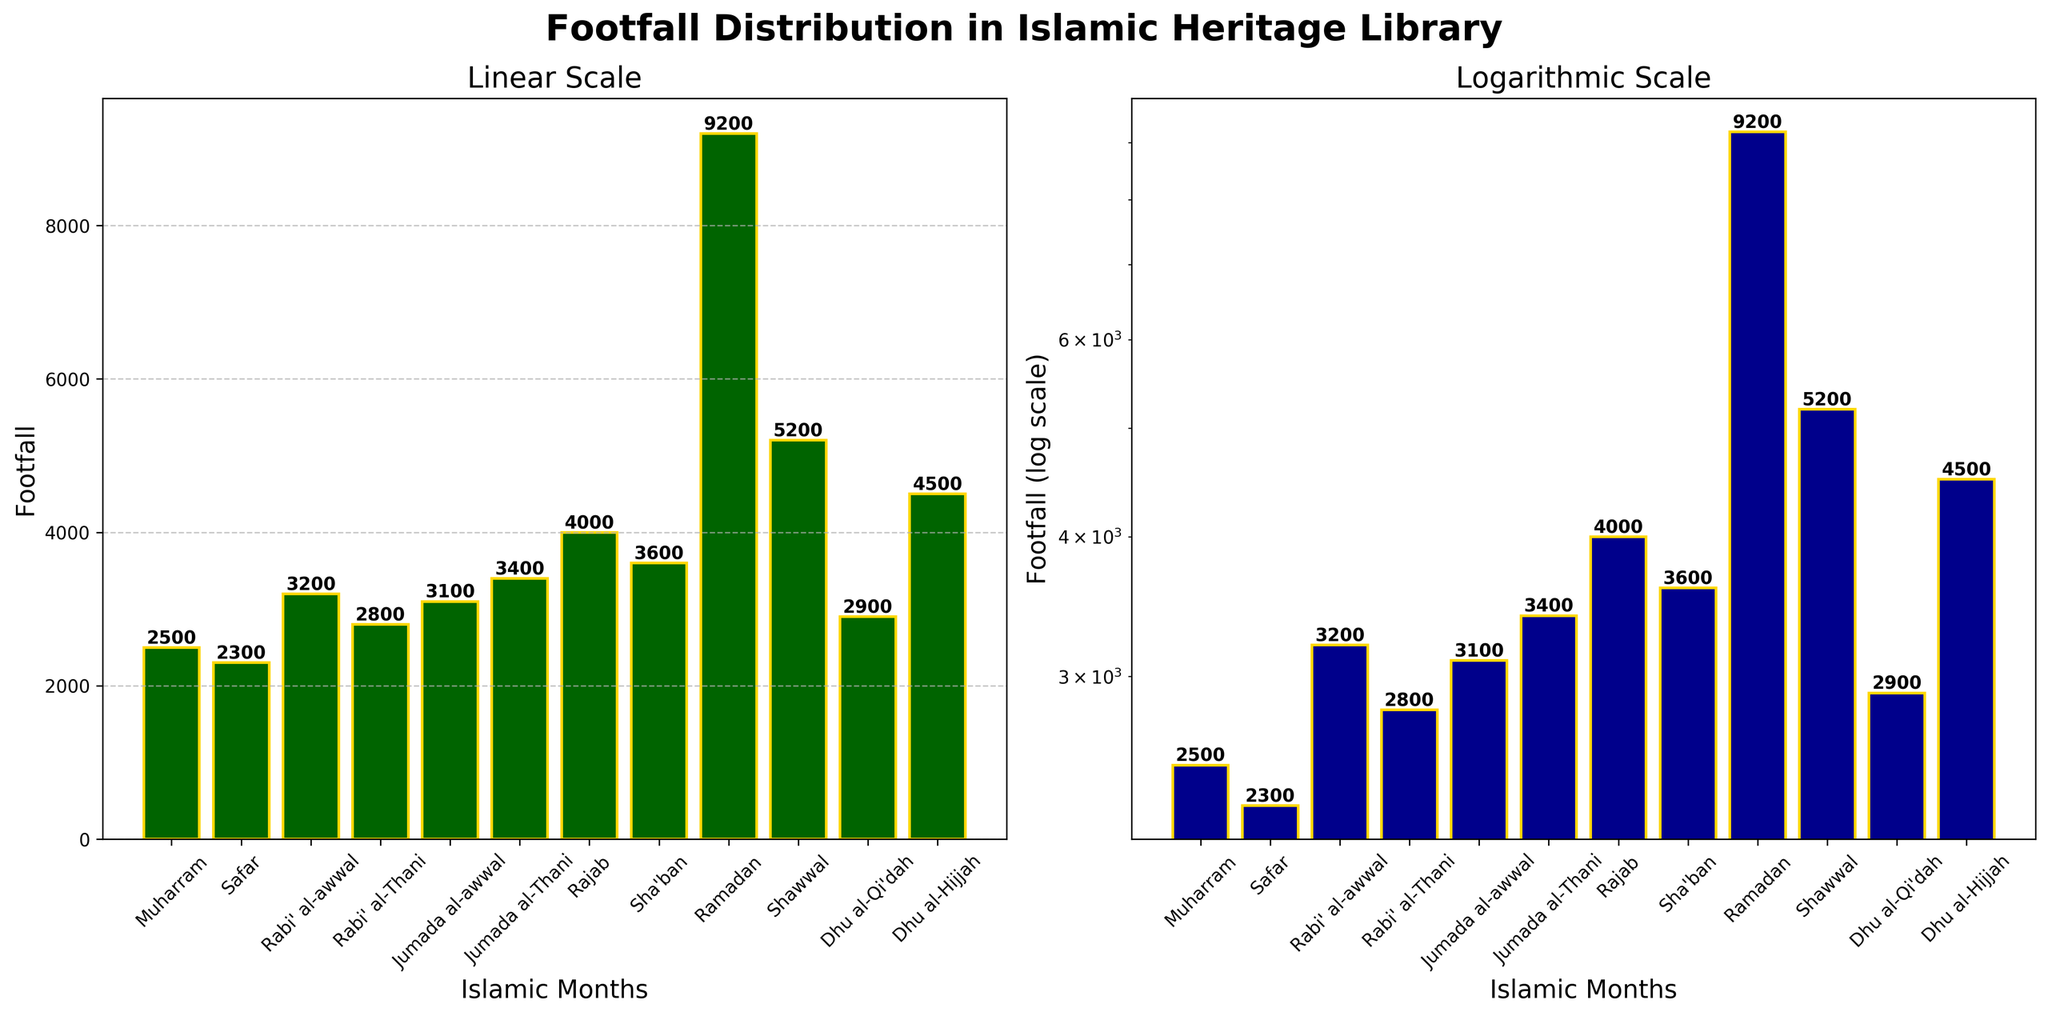Which month experiences the highest footfall? In both the linear and logarithmic scale plots, the month with the highest bar is Ramadan. This height indicates the highest footfall, which is shown as 9200.
Answer: Ramadan Which month experiences the lowest footfall? In both plots, the height of the bars can be compared. The shortest bar corresponds to Safar, indicating a footfall of 2300, which is the lowest.
Answer: Safar How does the footfall in Shawwal compare to that in Sha'ban? In the linear plot, the bar for Shawwal is notable for being taller, indicating a higher footfall. Shawwal has 5200 footfalls, whereas Sha'ban has 3600.
Answer: Shawwal is higher What is the total footfall during the first three months? Sum the footfall values of Muharram (2500), Safar (2300), and Rabi' al-awwal (3200): 2500 + 2300 + 3200 = 8000.
Answer: 8000 Which months have footfall counts that are above 4000? Checking both plots, the months with bars surpassing the 4000 mark are Rajab (4000), Ramadan (9200), Shawwal (5200), and Dhu al-Hijjah (4500).
Answer: Rajab, Ramadan, Shawwal, Dhu al-Hijjah How much more footfall does Ramadan have compared to Muharram? The footfall for Ramadan and Muharram are 9200 and 2500 respectively. Subtract Muharram's footfall from Ramadan’s: 9200 - 2500 = 6700.
Answer: 6700 What is the average footfall across all months? Sum all the footfalls and divide by 12: (2500 + 2300 + 3200 + 2800 + 3100 + 3400 + 4000 + 3600 + 9200 + 5200 + 2900 + 4500) / 12 = 45,700 / 12 ≈ 3808.33.
Answer: ≈ 3808.33 Explain the trend in footfall during Ramadan using the log scale plot. On the log scale, Ramadan's bar is the tallest, indicating a significant increase compared to other months. This suggests a sharp rise in footfall during Ramadan, far more pronounced based on the logarithmic representation.
Answer: Significant increase Compare the footfall distribution in linear and log scales. The linear scale shows absolute differences, indicating Ramadan’s footfall as extremely high. The log scale compresses the differences but emphasizes proportional changes, still reflecting Ramadan’s high footfall distinctly.
Answer: Linear: absolute; Log: proportional Which months show a footfall pattern just below the average? The average footfall calculated is approximately 3808.33. Months with footfalls slightly below this average are Sha'ban (3600) and Jumada al-Thani (3400).
Answer: Sha'ban, Jumada al-Thani 